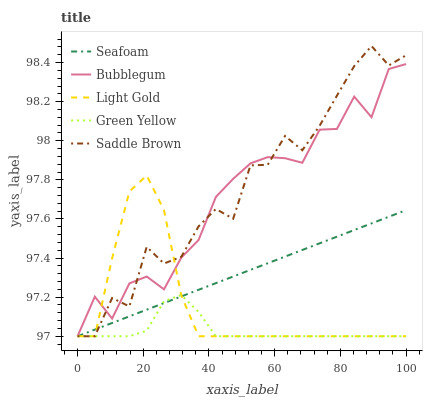Does Green Yellow have the minimum area under the curve?
Answer yes or no. Yes. Does Saddle Brown have the maximum area under the curve?
Answer yes or no. Yes. Does Light Gold have the minimum area under the curve?
Answer yes or no. No. Does Light Gold have the maximum area under the curve?
Answer yes or no. No. Is Seafoam the smoothest?
Answer yes or no. Yes. Is Saddle Brown the roughest?
Answer yes or no. Yes. Is Light Gold the smoothest?
Answer yes or no. No. Is Light Gold the roughest?
Answer yes or no. No. Does Green Yellow have the lowest value?
Answer yes or no. Yes. Does Saddle Brown have the highest value?
Answer yes or no. Yes. Does Light Gold have the highest value?
Answer yes or no. No. Does Saddle Brown intersect Light Gold?
Answer yes or no. Yes. Is Saddle Brown less than Light Gold?
Answer yes or no. No. Is Saddle Brown greater than Light Gold?
Answer yes or no. No. 